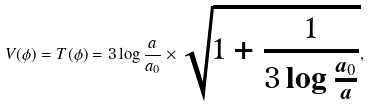<formula> <loc_0><loc_0><loc_500><loc_500>V ( \phi ) = T ( \phi ) = 3 \log \frac { a } { a _ { 0 } } \times \sqrt { 1 + \frac { 1 } { 3 \log \frac { a _ { 0 } } { a } } } ,</formula> 